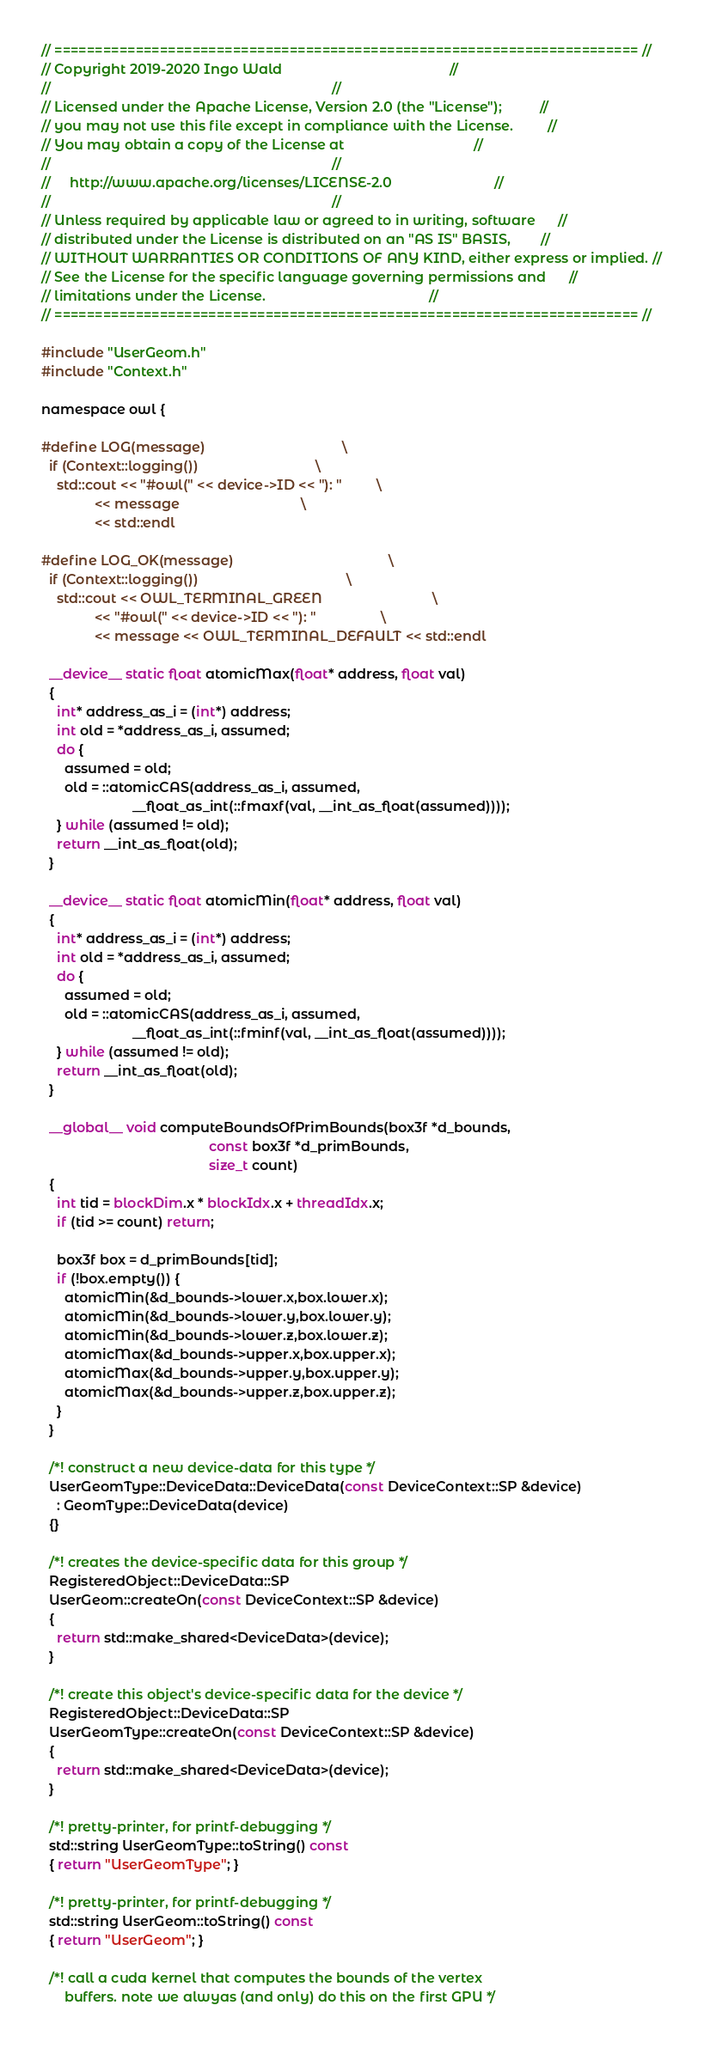Convert code to text. <code><loc_0><loc_0><loc_500><loc_500><_Cuda_>// ======================================================================== //
// Copyright 2019-2020 Ingo Wald                                            //
//                                                                          //
// Licensed under the Apache License, Version 2.0 (the "License");          //
// you may not use this file except in compliance with the License.         //
// You may obtain a copy of the License at                                  //
//                                                                          //
//     http://www.apache.org/licenses/LICENSE-2.0                           //
//                                                                          //
// Unless required by applicable law or agreed to in writing, software      //
// distributed under the License is distributed on an "AS IS" BASIS,        //
// WITHOUT WARRANTIES OR CONDITIONS OF ANY KIND, either express or implied. //
// See the License for the specific language governing permissions and      //
// limitations under the License.                                           //
// ======================================================================== //

#include "UserGeom.h"
#include "Context.h"

namespace owl {

#define LOG(message)                                    \
  if (Context::logging())                               \
    std::cout << "#owl(" << device->ID << "): "         \
              << message                                \
              << std::endl

#define LOG_OK(message)                                         \
  if (Context::logging())                                       \
    std::cout << OWL_TERMINAL_GREEN                             \
              << "#owl(" << device->ID << "): "                 \
              << message << OWL_TERMINAL_DEFAULT << std::endl

  __device__ static float atomicMax(float* address, float val)
  {
    int* address_as_i = (int*) address;
    int old = *address_as_i, assumed;
    do {
      assumed = old;
      old = ::atomicCAS(address_as_i, assumed,
                        __float_as_int(::fmaxf(val, __int_as_float(assumed))));
    } while (assumed != old);
    return __int_as_float(old);
  }
  
  __device__ static float atomicMin(float* address, float val)
  {
    int* address_as_i = (int*) address;
    int old = *address_as_i, assumed;
    do {
      assumed = old;
      old = ::atomicCAS(address_as_i, assumed,
                        __float_as_int(::fminf(val, __int_as_float(assumed))));
    } while (assumed != old);
    return __int_as_float(old);
  }
  
  __global__ void computeBoundsOfPrimBounds(box3f *d_bounds,
                                            const box3f *d_primBounds,
                                            size_t count)
  {
    int tid = blockDim.x * blockIdx.x + threadIdx.x;
    if (tid >= count) return;

    box3f box = d_primBounds[tid];
    if (!box.empty()) {
      atomicMin(&d_bounds->lower.x,box.lower.x);
      atomicMin(&d_bounds->lower.y,box.lower.y);
      atomicMin(&d_bounds->lower.z,box.lower.z);
      atomicMax(&d_bounds->upper.x,box.upper.x);
      atomicMax(&d_bounds->upper.y,box.upper.y);
      atomicMax(&d_bounds->upper.z,box.upper.z);
    }
  }
                                          
  /*! construct a new device-data for this type */
  UserGeomType::DeviceData::DeviceData(const DeviceContext::SP &device)
    : GeomType::DeviceData(device)
  {}

  /*! creates the device-specific data for this group */
  RegisteredObject::DeviceData::SP
  UserGeom::createOn(const DeviceContext::SP &device) 
  {
    return std::make_shared<DeviceData>(device);
  }

  /*! create this object's device-specific data for the device */
  RegisteredObject::DeviceData::SP
  UserGeomType::createOn(const DeviceContext::SP &device) 
  {
    return std::make_shared<DeviceData>(device);
  }

  /*! pretty-printer, for printf-debugging */
  std::string UserGeomType::toString() const
  { return "UserGeomType"; }

  /*! pretty-printer, for printf-debugging */
  std::string UserGeom::toString() const
  { return "UserGeom"; }
  
  /*! call a cuda kernel that computes the bounds of the vertex
      buffers. note we alwyas (and only) do this on the first GPU */</code> 